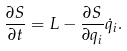<formula> <loc_0><loc_0><loc_500><loc_500>\frac { \partial S } { \partial t } = L - \frac { \partial S } { \partial q _ { i } } \dot { q } _ { i } .</formula> 